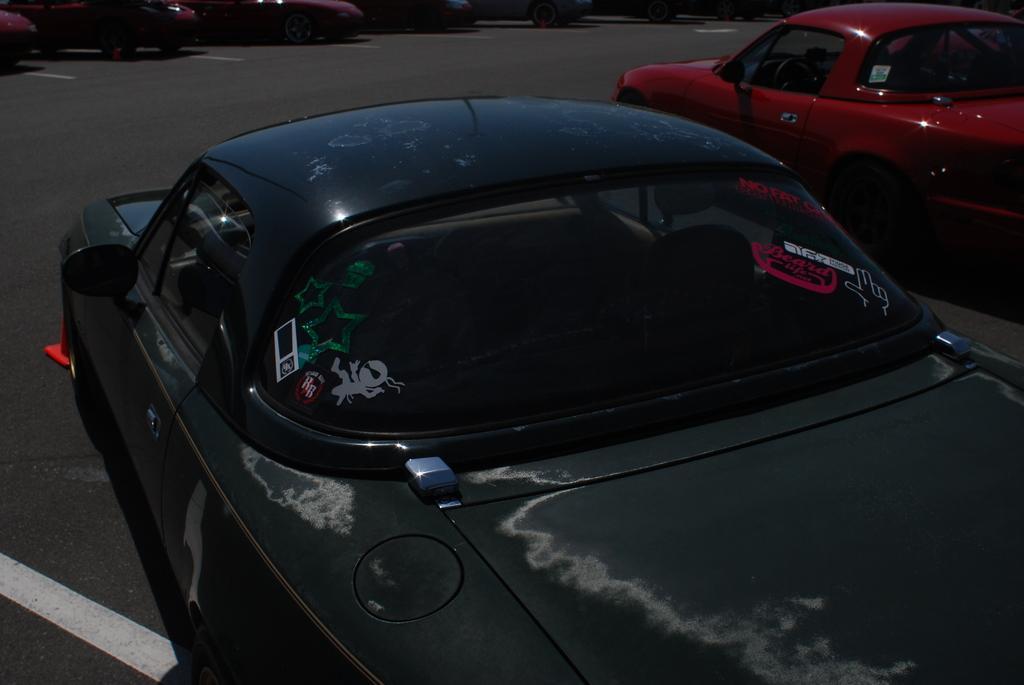Could you give a brief overview of what you see in this image? In this image we can see a few vehicles on the road. 